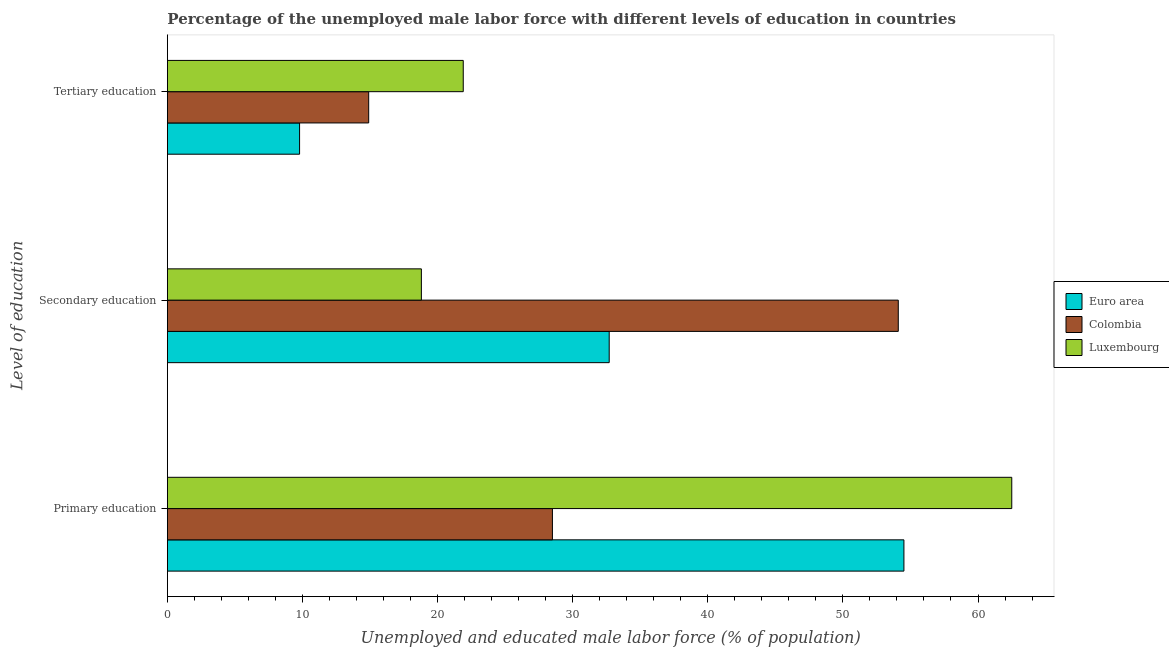How many groups of bars are there?
Offer a terse response. 3. Are the number of bars per tick equal to the number of legend labels?
Keep it short and to the point. Yes. How many bars are there on the 1st tick from the bottom?
Your answer should be very brief. 3. What is the label of the 1st group of bars from the top?
Keep it short and to the point. Tertiary education. What is the percentage of male labor force who received primary education in Euro area?
Your answer should be compact. 54.52. Across all countries, what is the maximum percentage of male labor force who received tertiary education?
Offer a very short reply. 21.9. Across all countries, what is the minimum percentage of male labor force who received tertiary education?
Provide a succinct answer. 9.78. In which country was the percentage of male labor force who received tertiary education maximum?
Offer a very short reply. Luxembourg. In which country was the percentage of male labor force who received tertiary education minimum?
Your answer should be compact. Euro area. What is the total percentage of male labor force who received secondary education in the graph?
Ensure brevity in your answer.  105.6. What is the difference between the percentage of male labor force who received secondary education in Euro area and that in Luxembourg?
Give a very brief answer. 13.9. What is the difference between the percentage of male labor force who received primary education in Luxembourg and the percentage of male labor force who received secondary education in Colombia?
Offer a very short reply. 8.4. What is the average percentage of male labor force who received secondary education per country?
Your response must be concise. 35.2. What is the difference between the percentage of male labor force who received secondary education and percentage of male labor force who received primary education in Luxembourg?
Offer a terse response. -43.7. In how many countries, is the percentage of male labor force who received secondary education greater than 44 %?
Your answer should be compact. 1. What is the ratio of the percentage of male labor force who received tertiary education in Colombia to that in Luxembourg?
Your response must be concise. 0.68. Is the percentage of male labor force who received tertiary education in Luxembourg less than that in Euro area?
Offer a terse response. No. Is the difference between the percentage of male labor force who received tertiary education in Luxembourg and Colombia greater than the difference between the percentage of male labor force who received primary education in Luxembourg and Colombia?
Make the answer very short. No. What is the difference between the highest and the second highest percentage of male labor force who received tertiary education?
Your answer should be compact. 7. What is the difference between the highest and the lowest percentage of male labor force who received primary education?
Ensure brevity in your answer.  34. In how many countries, is the percentage of male labor force who received tertiary education greater than the average percentage of male labor force who received tertiary education taken over all countries?
Keep it short and to the point. 1. Is the sum of the percentage of male labor force who received tertiary education in Luxembourg and Euro area greater than the maximum percentage of male labor force who received primary education across all countries?
Your answer should be compact. No. What does the 1st bar from the top in Primary education represents?
Offer a terse response. Luxembourg. What does the 3rd bar from the bottom in Primary education represents?
Your answer should be compact. Luxembourg. How many bars are there?
Your answer should be compact. 9. How many countries are there in the graph?
Ensure brevity in your answer.  3. What is the difference between two consecutive major ticks on the X-axis?
Offer a very short reply. 10. Are the values on the major ticks of X-axis written in scientific E-notation?
Keep it short and to the point. No. Where does the legend appear in the graph?
Your response must be concise. Center right. What is the title of the graph?
Provide a short and direct response. Percentage of the unemployed male labor force with different levels of education in countries. What is the label or title of the X-axis?
Provide a short and direct response. Unemployed and educated male labor force (% of population). What is the label or title of the Y-axis?
Keep it short and to the point. Level of education. What is the Unemployed and educated male labor force (% of population) in Euro area in Primary education?
Offer a terse response. 54.52. What is the Unemployed and educated male labor force (% of population) in Luxembourg in Primary education?
Make the answer very short. 62.5. What is the Unemployed and educated male labor force (% of population) of Euro area in Secondary education?
Make the answer very short. 32.7. What is the Unemployed and educated male labor force (% of population) of Colombia in Secondary education?
Your response must be concise. 54.1. What is the Unemployed and educated male labor force (% of population) of Luxembourg in Secondary education?
Your answer should be compact. 18.8. What is the Unemployed and educated male labor force (% of population) in Euro area in Tertiary education?
Offer a very short reply. 9.78. What is the Unemployed and educated male labor force (% of population) in Colombia in Tertiary education?
Your response must be concise. 14.9. What is the Unemployed and educated male labor force (% of population) of Luxembourg in Tertiary education?
Provide a short and direct response. 21.9. Across all Level of education, what is the maximum Unemployed and educated male labor force (% of population) in Euro area?
Offer a terse response. 54.52. Across all Level of education, what is the maximum Unemployed and educated male labor force (% of population) in Colombia?
Provide a succinct answer. 54.1. Across all Level of education, what is the maximum Unemployed and educated male labor force (% of population) of Luxembourg?
Offer a terse response. 62.5. Across all Level of education, what is the minimum Unemployed and educated male labor force (% of population) in Euro area?
Your response must be concise. 9.78. Across all Level of education, what is the minimum Unemployed and educated male labor force (% of population) in Colombia?
Your answer should be very brief. 14.9. Across all Level of education, what is the minimum Unemployed and educated male labor force (% of population) in Luxembourg?
Provide a succinct answer. 18.8. What is the total Unemployed and educated male labor force (% of population) of Euro area in the graph?
Your answer should be compact. 97. What is the total Unemployed and educated male labor force (% of population) of Colombia in the graph?
Your response must be concise. 97.5. What is the total Unemployed and educated male labor force (% of population) in Luxembourg in the graph?
Ensure brevity in your answer.  103.2. What is the difference between the Unemployed and educated male labor force (% of population) in Euro area in Primary education and that in Secondary education?
Provide a short and direct response. 21.81. What is the difference between the Unemployed and educated male labor force (% of population) in Colombia in Primary education and that in Secondary education?
Keep it short and to the point. -25.6. What is the difference between the Unemployed and educated male labor force (% of population) of Luxembourg in Primary education and that in Secondary education?
Offer a terse response. 43.7. What is the difference between the Unemployed and educated male labor force (% of population) of Euro area in Primary education and that in Tertiary education?
Offer a very short reply. 44.73. What is the difference between the Unemployed and educated male labor force (% of population) of Colombia in Primary education and that in Tertiary education?
Provide a short and direct response. 13.6. What is the difference between the Unemployed and educated male labor force (% of population) in Luxembourg in Primary education and that in Tertiary education?
Offer a very short reply. 40.6. What is the difference between the Unemployed and educated male labor force (% of population) of Euro area in Secondary education and that in Tertiary education?
Keep it short and to the point. 22.92. What is the difference between the Unemployed and educated male labor force (% of population) in Colombia in Secondary education and that in Tertiary education?
Your response must be concise. 39.2. What is the difference between the Unemployed and educated male labor force (% of population) in Euro area in Primary education and the Unemployed and educated male labor force (% of population) in Colombia in Secondary education?
Keep it short and to the point. 0.42. What is the difference between the Unemployed and educated male labor force (% of population) of Euro area in Primary education and the Unemployed and educated male labor force (% of population) of Luxembourg in Secondary education?
Your answer should be very brief. 35.72. What is the difference between the Unemployed and educated male labor force (% of population) in Colombia in Primary education and the Unemployed and educated male labor force (% of population) in Luxembourg in Secondary education?
Your response must be concise. 9.7. What is the difference between the Unemployed and educated male labor force (% of population) in Euro area in Primary education and the Unemployed and educated male labor force (% of population) in Colombia in Tertiary education?
Give a very brief answer. 39.62. What is the difference between the Unemployed and educated male labor force (% of population) in Euro area in Primary education and the Unemployed and educated male labor force (% of population) in Luxembourg in Tertiary education?
Make the answer very short. 32.62. What is the difference between the Unemployed and educated male labor force (% of population) of Euro area in Secondary education and the Unemployed and educated male labor force (% of population) of Colombia in Tertiary education?
Your answer should be very brief. 17.8. What is the difference between the Unemployed and educated male labor force (% of population) of Euro area in Secondary education and the Unemployed and educated male labor force (% of population) of Luxembourg in Tertiary education?
Offer a very short reply. 10.8. What is the difference between the Unemployed and educated male labor force (% of population) in Colombia in Secondary education and the Unemployed and educated male labor force (% of population) in Luxembourg in Tertiary education?
Ensure brevity in your answer.  32.2. What is the average Unemployed and educated male labor force (% of population) in Euro area per Level of education?
Your answer should be compact. 32.34. What is the average Unemployed and educated male labor force (% of population) in Colombia per Level of education?
Make the answer very short. 32.5. What is the average Unemployed and educated male labor force (% of population) of Luxembourg per Level of education?
Offer a very short reply. 34.4. What is the difference between the Unemployed and educated male labor force (% of population) in Euro area and Unemployed and educated male labor force (% of population) in Colombia in Primary education?
Ensure brevity in your answer.  26.02. What is the difference between the Unemployed and educated male labor force (% of population) in Euro area and Unemployed and educated male labor force (% of population) in Luxembourg in Primary education?
Provide a short and direct response. -7.98. What is the difference between the Unemployed and educated male labor force (% of population) of Colombia and Unemployed and educated male labor force (% of population) of Luxembourg in Primary education?
Keep it short and to the point. -34. What is the difference between the Unemployed and educated male labor force (% of population) of Euro area and Unemployed and educated male labor force (% of population) of Colombia in Secondary education?
Provide a succinct answer. -21.4. What is the difference between the Unemployed and educated male labor force (% of population) in Euro area and Unemployed and educated male labor force (% of population) in Luxembourg in Secondary education?
Your answer should be very brief. 13.9. What is the difference between the Unemployed and educated male labor force (% of population) of Colombia and Unemployed and educated male labor force (% of population) of Luxembourg in Secondary education?
Keep it short and to the point. 35.3. What is the difference between the Unemployed and educated male labor force (% of population) of Euro area and Unemployed and educated male labor force (% of population) of Colombia in Tertiary education?
Your answer should be compact. -5.12. What is the difference between the Unemployed and educated male labor force (% of population) of Euro area and Unemployed and educated male labor force (% of population) of Luxembourg in Tertiary education?
Provide a succinct answer. -12.12. What is the difference between the Unemployed and educated male labor force (% of population) of Colombia and Unemployed and educated male labor force (% of population) of Luxembourg in Tertiary education?
Your answer should be very brief. -7. What is the ratio of the Unemployed and educated male labor force (% of population) in Euro area in Primary education to that in Secondary education?
Your answer should be compact. 1.67. What is the ratio of the Unemployed and educated male labor force (% of population) in Colombia in Primary education to that in Secondary education?
Ensure brevity in your answer.  0.53. What is the ratio of the Unemployed and educated male labor force (% of population) of Luxembourg in Primary education to that in Secondary education?
Offer a terse response. 3.32. What is the ratio of the Unemployed and educated male labor force (% of population) of Euro area in Primary education to that in Tertiary education?
Your answer should be very brief. 5.57. What is the ratio of the Unemployed and educated male labor force (% of population) in Colombia in Primary education to that in Tertiary education?
Your response must be concise. 1.91. What is the ratio of the Unemployed and educated male labor force (% of population) of Luxembourg in Primary education to that in Tertiary education?
Your answer should be very brief. 2.85. What is the ratio of the Unemployed and educated male labor force (% of population) of Euro area in Secondary education to that in Tertiary education?
Your answer should be compact. 3.34. What is the ratio of the Unemployed and educated male labor force (% of population) in Colombia in Secondary education to that in Tertiary education?
Offer a very short reply. 3.63. What is the ratio of the Unemployed and educated male labor force (% of population) of Luxembourg in Secondary education to that in Tertiary education?
Your answer should be compact. 0.86. What is the difference between the highest and the second highest Unemployed and educated male labor force (% of population) in Euro area?
Ensure brevity in your answer.  21.81. What is the difference between the highest and the second highest Unemployed and educated male labor force (% of population) in Colombia?
Your answer should be very brief. 25.6. What is the difference between the highest and the second highest Unemployed and educated male labor force (% of population) of Luxembourg?
Give a very brief answer. 40.6. What is the difference between the highest and the lowest Unemployed and educated male labor force (% of population) in Euro area?
Give a very brief answer. 44.73. What is the difference between the highest and the lowest Unemployed and educated male labor force (% of population) in Colombia?
Offer a terse response. 39.2. What is the difference between the highest and the lowest Unemployed and educated male labor force (% of population) of Luxembourg?
Your response must be concise. 43.7. 